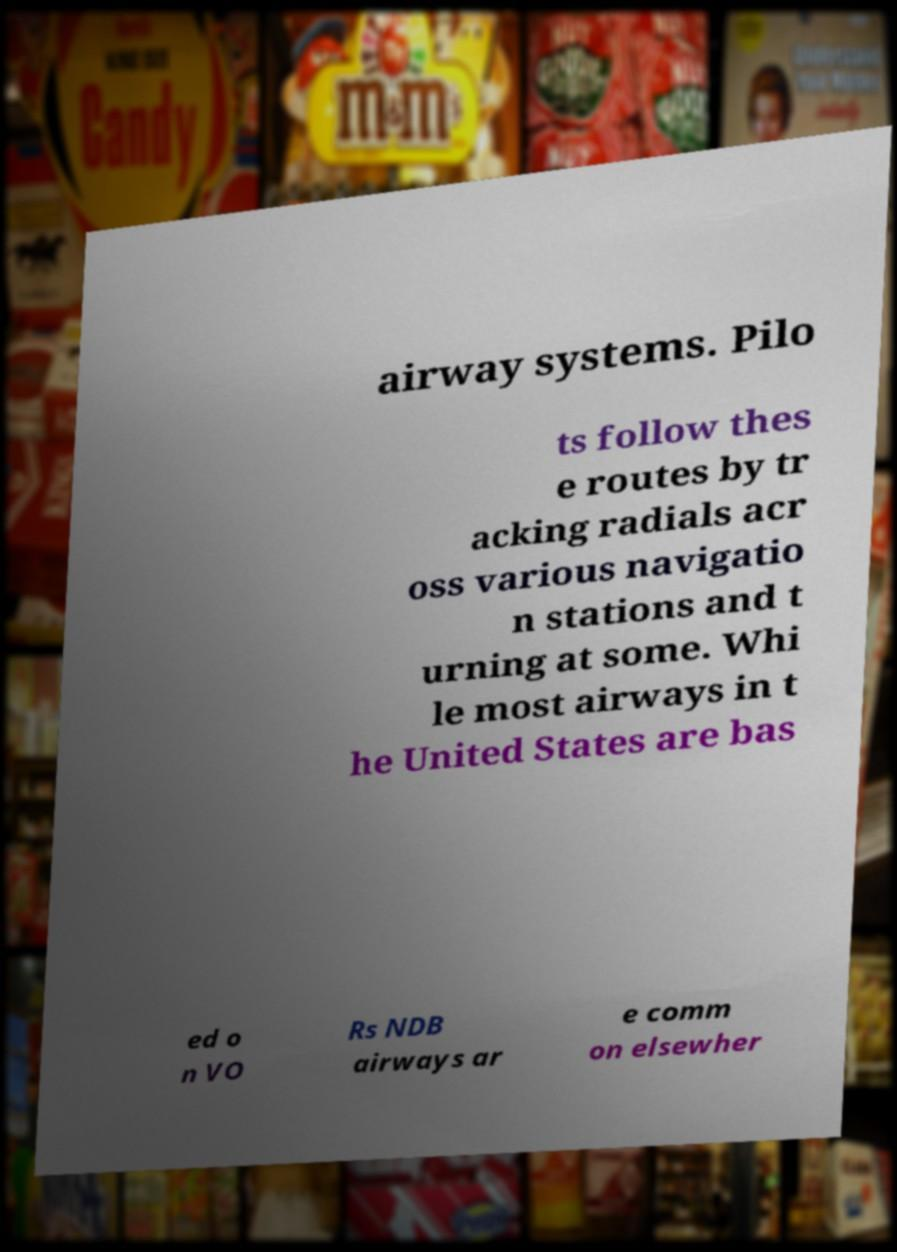Can you read and provide the text displayed in the image?This photo seems to have some interesting text. Can you extract and type it out for me? airway systems. Pilo ts follow thes e routes by tr acking radials acr oss various navigatio n stations and t urning at some. Whi le most airways in t he United States are bas ed o n VO Rs NDB airways ar e comm on elsewher 